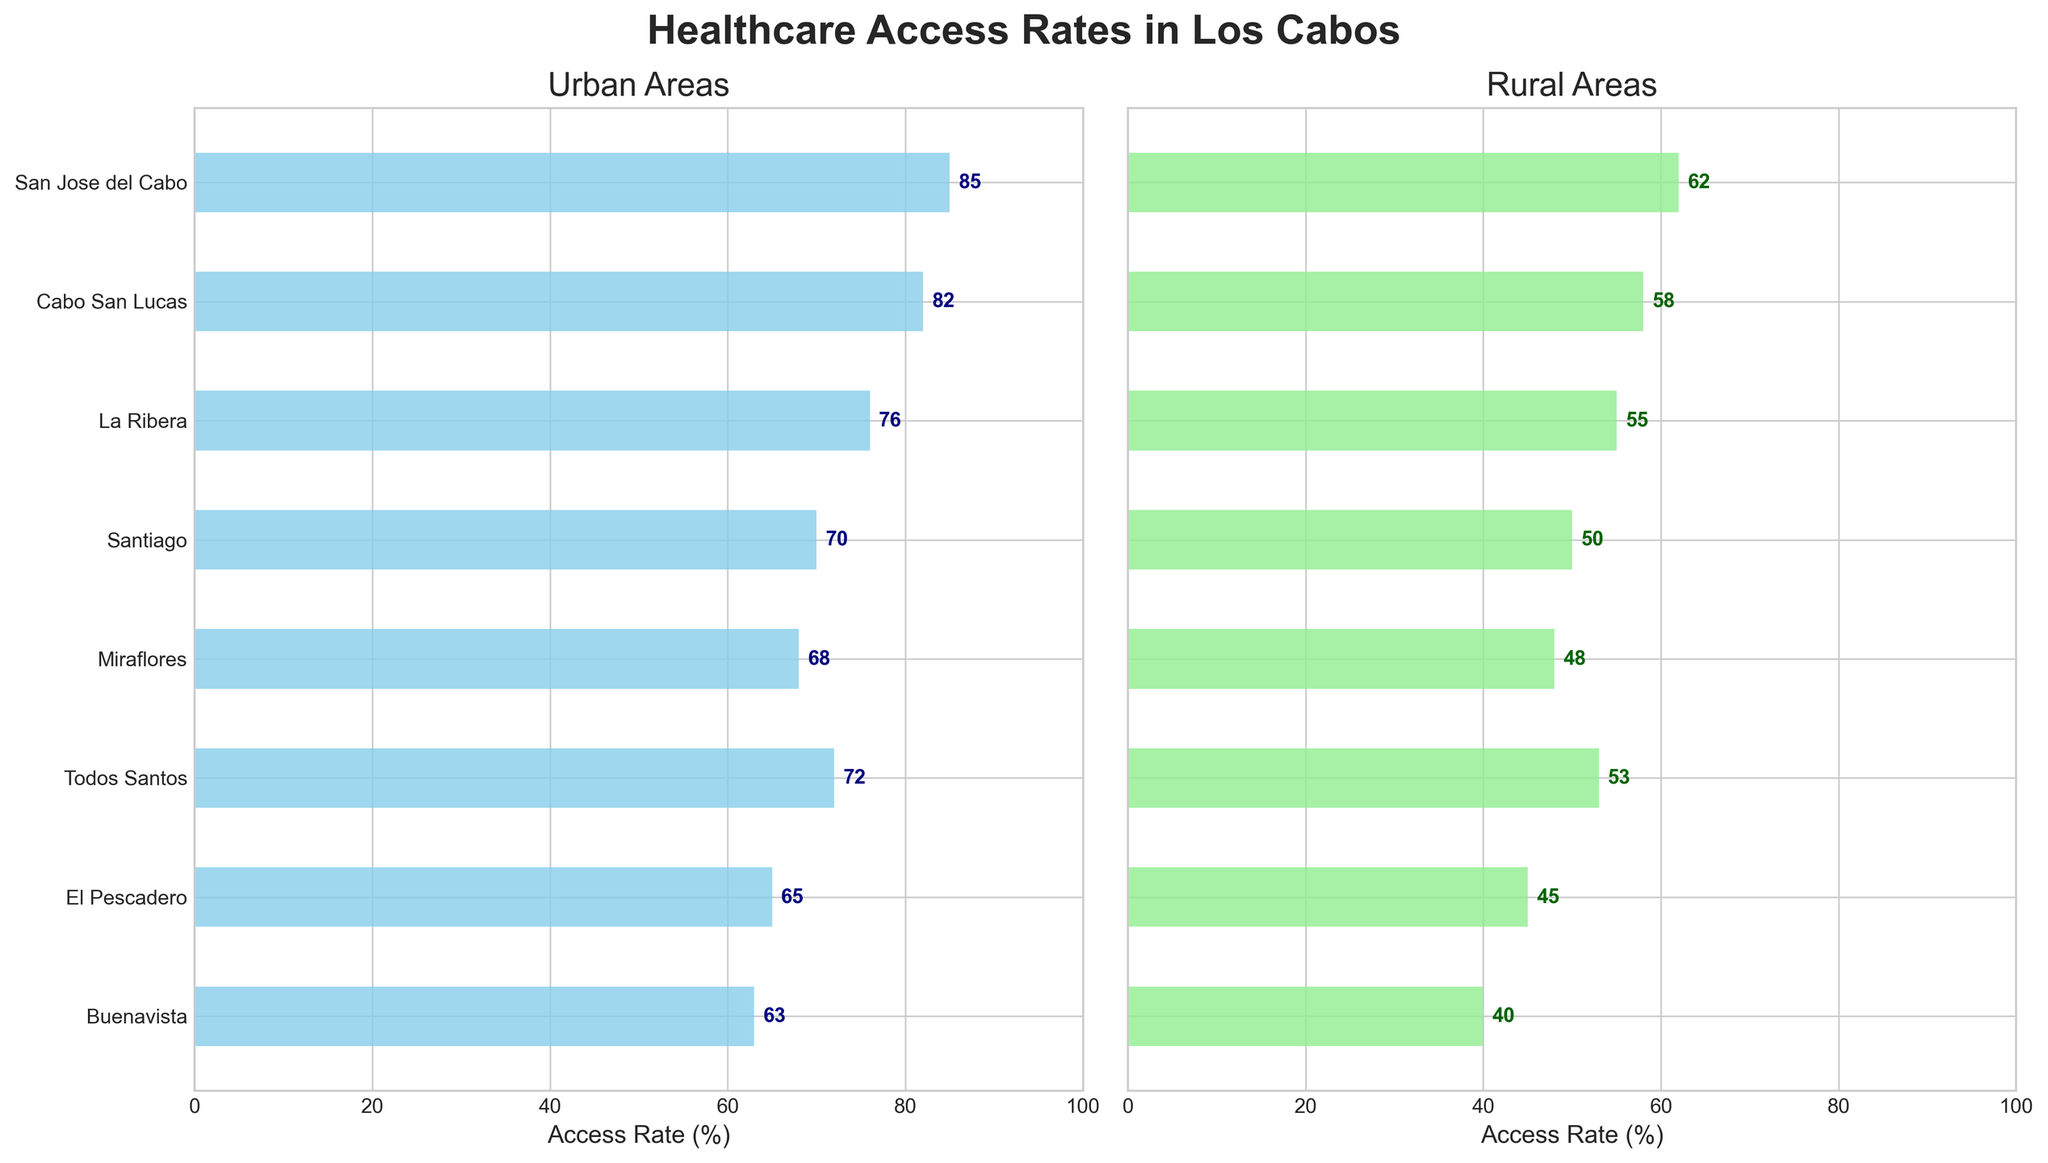What are the titles of the two subplots? The title for the first subplot is "Urban Areas," and the title for the second subplot is "Rural Areas." You can find these at the top of each subplot.
Answer: Urban Areas, Rural Areas Which district has the highest urban healthcare access rate? The highest urban healthcare access rate is indicated by the longest bar in the "Urban Areas" subplot. This bar belongs to "San Jose del Cabo" with a rate of 85%.
Answer: San Jose del Cabo Which district shows the greatest difference between urban and rural access rates? To find the district with the greatest difference, subtract the rural rate from the urban rate for each district. The largest difference is found in "San Jose del Cabo," where the difference is 85 - 62 = 23%.
Answer: San Jose del Cabo What is the average urban healthcare access rate across all districts? Add the urban access rates for all districts and divide by the number of districts. The total is 85 + 82 + 76 + 70 + 68 + 72 + 65 + 63 = 581. Divide by 8 (number of districts): 581 / 8 = 72.625%.
Answer: 72.625% What is the minimum rural access rate present in the figure? The minimum rural access rate can be found in the "Rural Areas" subplot, where the shortest bar denotes the lowest rate. "Buenavista" has the lowest rate of 40%.
Answer: 40% Which districts have urban access rates greater than 80%? Inspect the "Urban Areas" subplot for bars exceeding the 80% mark. "San Jose del Cabo" with 85% and "Cabo San Lucas" with 82% fit this criterion.
Answer: San Jose del Cabo, Cabo San Lucas By how much is the urban rate in "La Ribera" higher than its rural rate? In "La Ribera," the urban access rate is 76%, and the rural rate is 55%. Subtract the rural rate from the urban rate: 76 - 55 = 21%.
Answer: 21% Do any districts have a rural access rate above 60%? Check the "Rural Areas" subplot for any bars exceeding the 60% mark. None of the districts have a rural access rate above 60%.
Answer: No Which district has the closest urban and rural access rates? To find the closest rates, calculate the difference for each district and identify the smallest difference. "Todos Santos" has the smallest difference with urban rate 72% and rural rate 53% (difference of 19%).
Answer: Todos Santos How does the rural access rate in "Cabo San Lucas" compare to that in "Miraflores"? Compare the heights of the bars for "Cabo San Lucas" and "Miraflores" in the "Rural Areas" subplot. "Cabo San Lucas" has a rural rate of 58%, and "Miraflores" has a rate of 48%. "Cabo San Lucas" has a higher rural access rate by 10%.
Answer: Cabo San Lucas has a higher rural access rate by 10% 